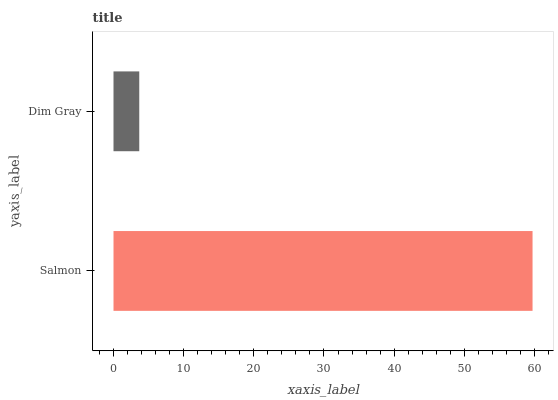Is Dim Gray the minimum?
Answer yes or no. Yes. Is Salmon the maximum?
Answer yes or no. Yes. Is Dim Gray the maximum?
Answer yes or no. No. Is Salmon greater than Dim Gray?
Answer yes or no. Yes. Is Dim Gray less than Salmon?
Answer yes or no. Yes. Is Dim Gray greater than Salmon?
Answer yes or no. No. Is Salmon less than Dim Gray?
Answer yes or no. No. Is Salmon the high median?
Answer yes or no. Yes. Is Dim Gray the low median?
Answer yes or no. Yes. Is Dim Gray the high median?
Answer yes or no. No. Is Salmon the low median?
Answer yes or no. No. 